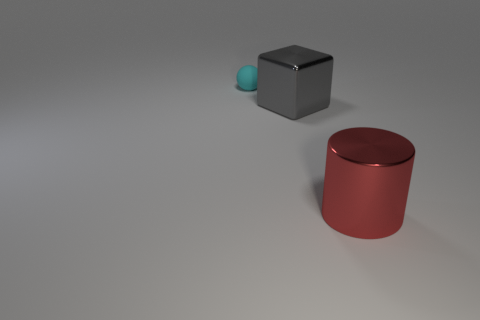Does the shiny thing left of the cylinder have the same size as the object that is behind the gray metallic object?
Keep it short and to the point. No. Are there any other large cyan objects that have the same shape as the matte object?
Keep it short and to the point. No. Are there the same number of tiny rubber balls that are to the left of the cyan ball and large metallic things?
Your answer should be compact. No. Does the red shiny thing have the same size as the shiny thing behind the large red cylinder?
Provide a succinct answer. Yes. What number of big gray cubes have the same material as the big red cylinder?
Ensure brevity in your answer.  1. Do the gray object and the cyan sphere have the same size?
Your response must be concise. No. Are there any other things that have the same color as the big cylinder?
Give a very brief answer. No. There is a thing that is behind the large red thing and in front of the small cyan ball; what shape is it?
Provide a short and direct response. Cube. There is a shiny thing on the left side of the cylinder; what is its size?
Make the answer very short. Large. What number of tiny matte things are to the left of the big metallic object to the right of the big shiny object left of the large red cylinder?
Offer a terse response. 1. 